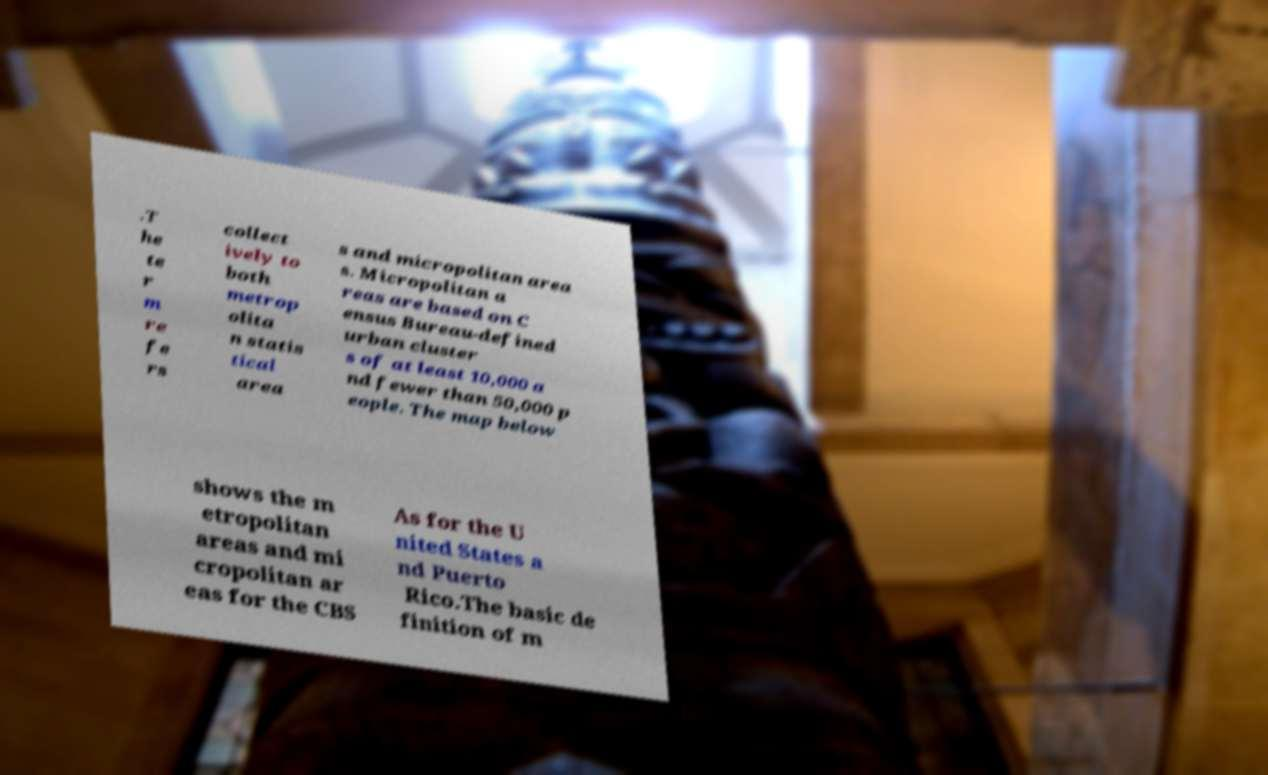Please identify and transcribe the text found in this image. .T he te r m re fe rs collect ively to both metrop olita n statis tical area s and micropolitan area s. Micropolitan a reas are based on C ensus Bureau-defined urban cluster s of at least 10,000 a nd fewer than 50,000 p eople. The map below shows the m etropolitan areas and mi cropolitan ar eas for the CBS As for the U nited States a nd Puerto Rico.The basic de finition of m 